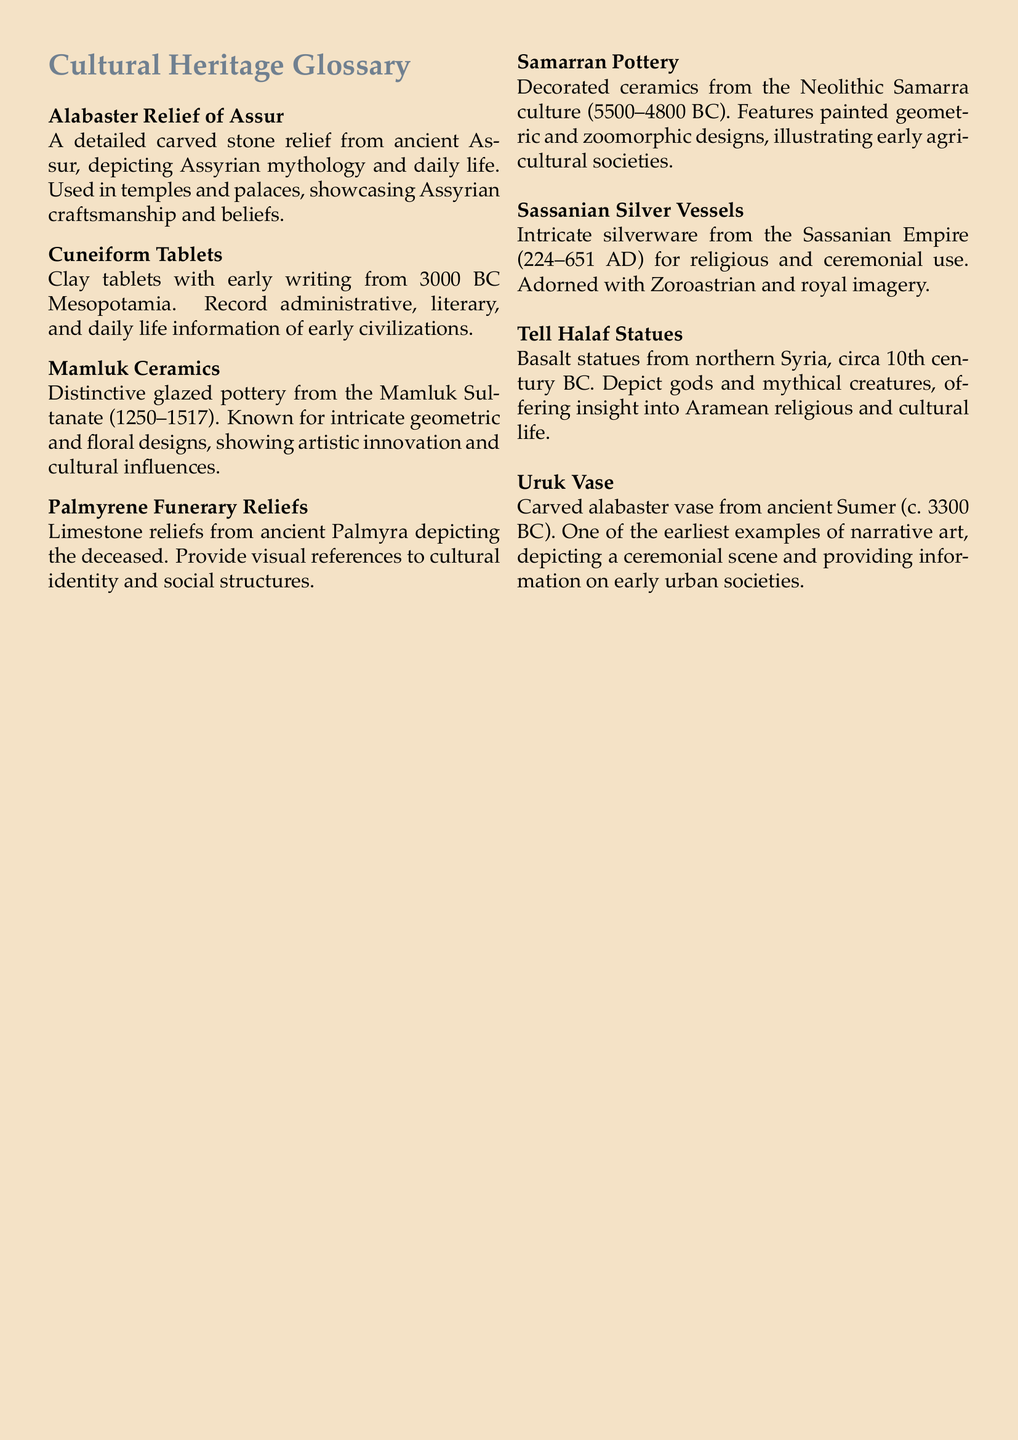What is the Alabaster Relief of Assur? The Alabaster Relief of Assur is a detailed carved stone relief from ancient Assur, depicting Assyrian mythology and daily life.
Answer: carved stone relief What period do Mamluk Ceramics belong to? Mamluk Ceramics are distinctive glazed pottery from the Mamluk Sultanate, which lasted from 1250 to 1517.
Answer: 1250–1517 Which empire produced Sassanian Silver Vessels? Sassanian Silver Vessels were produced during the Sassanian Empire, which existed from 224 to 651 AD.
Answer: Sassanian Empire What type of imagery adorns Sassanian Silver Vessels? Sassanian Silver Vessels are adorned with Zoroastrian and royal imagery.
Answer: Zoroastrian and royal imagery What do the Palmyrene Funerary Reliefs provide visual references to? The Palmyrene Funerary Reliefs provide visual references to cultural identity and social structures.
Answer: cultural identity and social structures What material are the Tell Halaf Statues made of? The Tell Halaf Statues are made of basalt.
Answer: basalt How do the Samarran Pottery designs illustrate early agricultural societies? The Samarran Pottery features painted geometric and zoomorphic designs, illustrating early agricultural societies.
Answer: painted geometric and zoomorphic designs What is depicted on the Uruk Vase? The Uruk Vase depicts a ceremonial scene.
Answer: ceremonial scene How many artifacts are listed in the document? The document lists a total of eight artifacts.
Answer: eight 